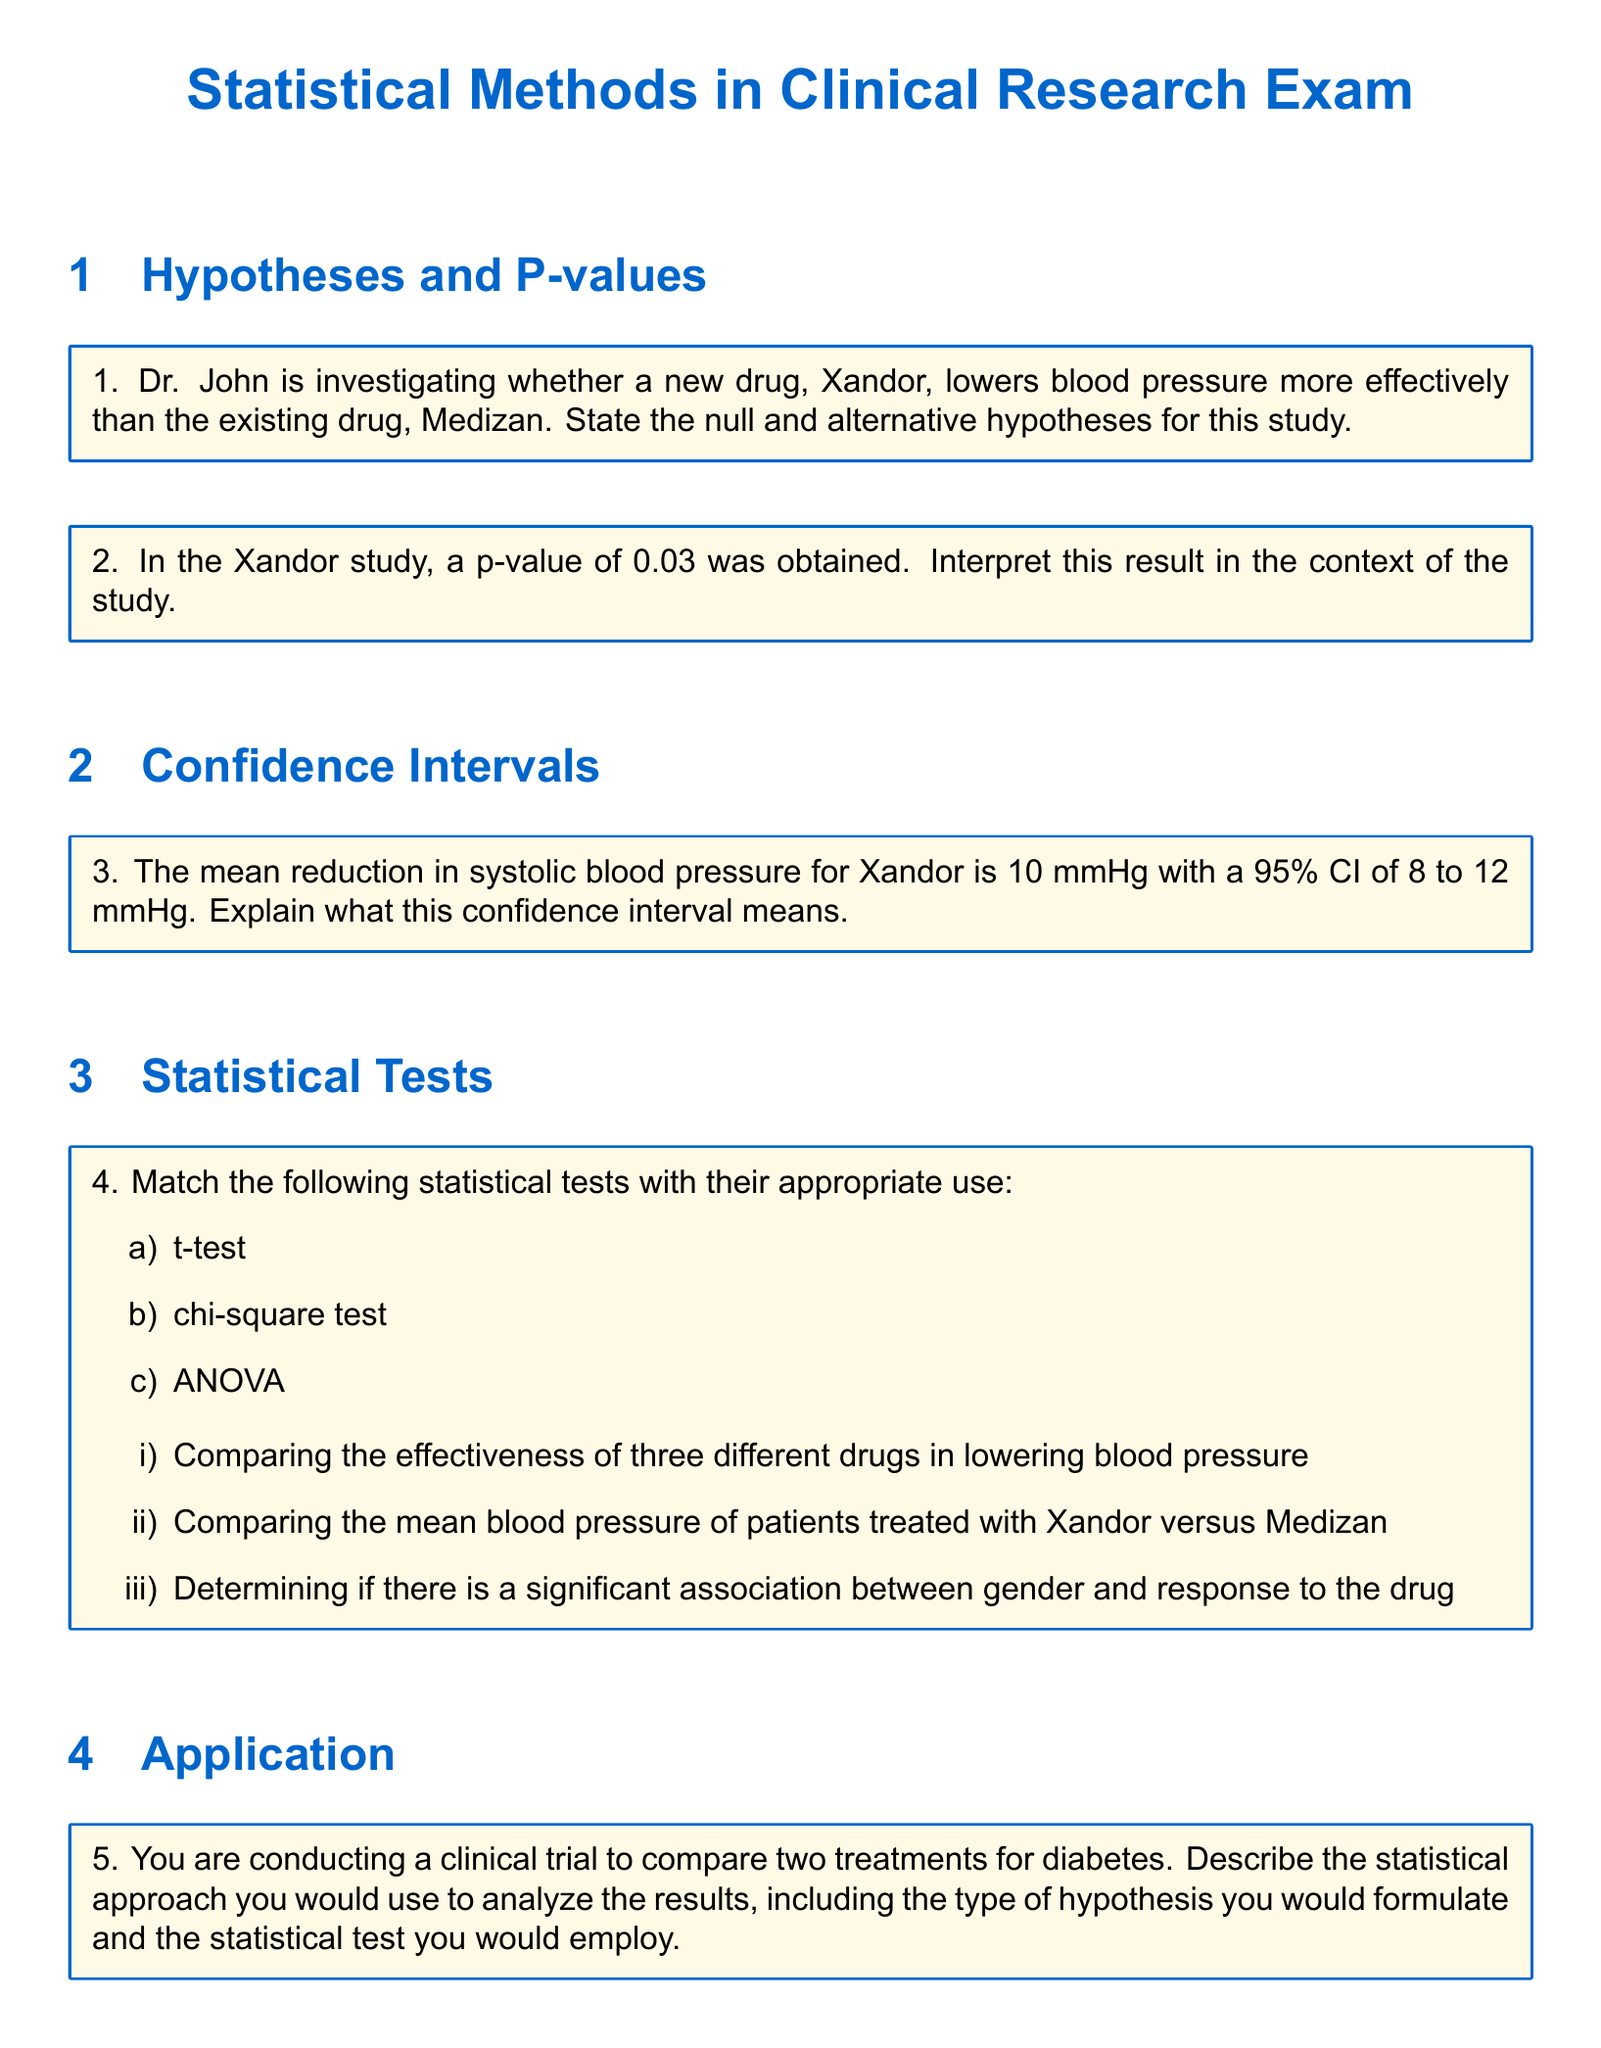What is the null hypothesis for the Xandor study? The null hypothesis typically states that there is no effect or difference; in this context, it would be that Xandor does not lower blood pressure more effectively than Medizan.
Answer: No difference What p-value was obtained in the Xandor study? The document states that a p-value of 0.03 was obtained in the study.
Answer: 0.03 What is the confidence interval for the mean reduction in systolic blood pressure for Xandor? The document specifies a 95% confidence interval of 8 to 12 mmHg for the mean reduction in systolic blood pressure.
Answer: 8 to 12 mmHg Which statistical test is appropriate for comparing the mean blood pressure of patients treated with Xandor versus Medizan? The document indicates a t-test is to be used for comparing the means of two independent groups.
Answer: t-test What was the mean reduction in systolic blood pressure for Xandor? According to the document, the mean reduction in systolic blood pressure for Xandor is 10 mmHg.
Answer: 10 mmHg What statistical test is used to compare the effectiveness of three different drugs in lowering blood pressure? The document describes that ANOVA is used for comparing the effectiveness of three different drugs.
Answer: ANOVA 